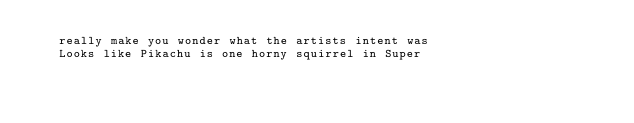Convert code to text. <code><loc_0><loc_0><loc_500><loc_500><_XML_>	 really make you wonder what the artists intent was 
	 Looks like Pikachu is one horny squirrel in Super </code> 